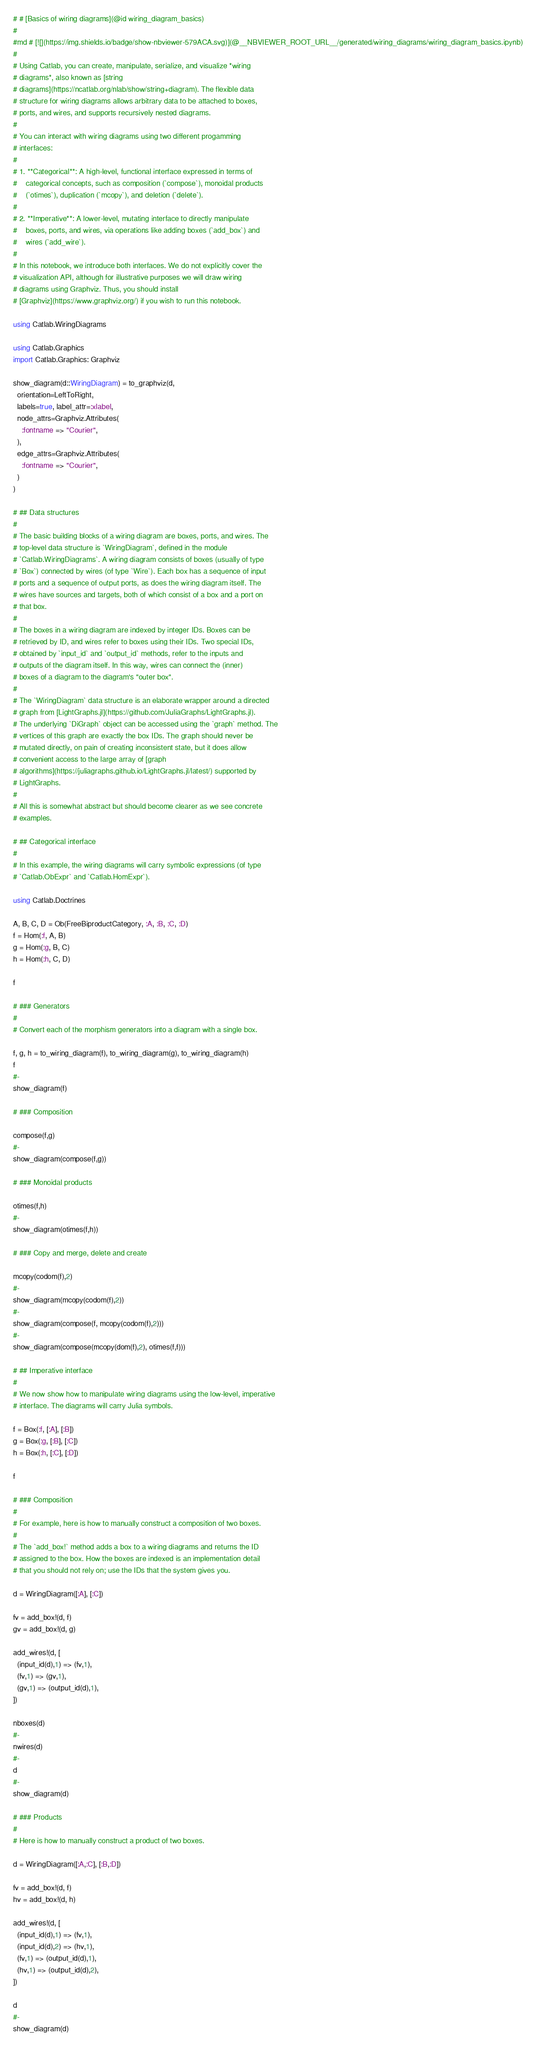<code> <loc_0><loc_0><loc_500><loc_500><_Julia_># # [Basics of wiring diagrams](@id wiring_diagram_basics)
#
#md # [![](https://img.shields.io/badge/show-nbviewer-579ACA.svg)](@__NBVIEWER_ROOT_URL__/generated/wiring_diagrams/wiring_diagram_basics.ipynb)
# 
# Using Catlab, you can create, manipulate, serialize, and visualize *wiring
# diagrams*, also known as [string
# diagrams](https://ncatlab.org/nlab/show/string+diagram). The flexible data
# structure for wiring diagrams allows arbitrary data to be attached to boxes,
# ports, and wires, and supports recursively nested diagrams.
# 
# You can interact with wiring diagrams using two different progamming
# interfaces:
# 
# 1. **Categorical**: A high-level, functional interface expressed in terms of
#    categorical concepts, such as composition (`compose`), monoidal products
#    (`otimes`), duplication (`mcopy`), and deletion (`delete`).
# 
# 2. **Imperative**: A lower-level, mutating interface to directly manipulate
#    boxes, ports, and wires, via operations like adding boxes (`add_box`) and
#    wires (`add_wire`).
# 
# In this notebook, we introduce both interfaces. We do not explicitly cover the
# visualization API, although for illustrative purposes we will draw wiring
# diagrams using Graphviz. Thus, you should install
# [Graphviz](https://www.graphviz.org/) if you wish to run this notebook.

using Catlab.WiringDiagrams

using Catlab.Graphics
import Catlab.Graphics: Graphviz

show_diagram(d::WiringDiagram) = to_graphviz(d,
  orientation=LeftToRight,
  labels=true, label_attr=:xlabel,
  node_attrs=Graphviz.Attributes(
    :fontname => "Courier",
  ),
  edge_attrs=Graphviz.Attributes(
    :fontname => "Courier",
  )
)

# ## Data structures
# 
# The basic building blocks of a wiring diagram are boxes, ports, and wires. The
# top-level data structure is `WiringDiagram`, defined in the module
# `Catlab.WiringDiagrams`. A wiring diagram consists of boxes (usually of type
# `Box`) connected by wires (of type `Wire`). Each box has a sequence of input
# ports and a sequence of output ports, as does the wiring diagram itself. The
# wires have sources and targets, both of which consist of a box and a port on
# that box.
# 
# The boxes in a wiring diagram are indexed by integer IDs. Boxes can be
# retrieved by ID, and wires refer to boxes using their IDs. Two special IDs,
# obtained by `input_id` and `output_id` methods, refer to the inputs and
# outputs of the diagram itself. In this way, wires can connect the (inner)
# boxes of a diagram to the diagram's "outer box".
# 
# The `WiringDiagram` data structure is an elaborate wrapper around a directed
# graph from [LightGraphs.jl](https://github.com/JuliaGraphs/LightGraphs.jl).
# The underlying `DiGraph` object can be accessed using the `graph` method. The
# vertices of this graph are exactly the box IDs. The graph should never be
# mutated directly, on pain of creating inconsistent state, but it does allow
# convenient access to the large array of [graph
# algorithms](https://juliagraphs.github.io/LightGraphs.jl/latest/) supported by
# LightGraphs.
# 
# All this is somewhat abstract but should become clearer as we see concrete 
# examples.

# ## Categorical interface
#
# In this example, the wiring diagrams will carry symbolic expressions (of type
# `Catlab.ObExpr` and `Catlab.HomExpr`).

using Catlab.Doctrines

A, B, C, D = Ob(FreeBiproductCategory, :A, :B, :C, :D)
f = Hom(:f, A, B)
g = Hom(:g, B, C)
h = Hom(:h, C, D)

f

# ### Generators
#
# Convert each of the morphism generators into a diagram with a single box.

f, g, h = to_wiring_diagram(f), to_wiring_diagram(g), to_wiring_diagram(h)
f
#-
show_diagram(f)

# ### Composition

compose(f,g)
#-
show_diagram(compose(f,g))

# ### Monoidal products

otimes(f,h)
#-
show_diagram(otimes(f,h))

# ### Copy and merge, delete and create

mcopy(codom(f),2)
#-
show_diagram(mcopy(codom(f),2))
#-
show_diagram(compose(f, mcopy(codom(f),2)))
#-
show_diagram(compose(mcopy(dom(f),2), otimes(f,f)))

# ## Imperative interface
#
# We now show how to manipulate wiring diagrams using the low-level, imperative
# interface. The diagrams will carry Julia symbols.

f = Box(:f, [:A], [:B])
g = Box(:g, [:B], [:C])
h = Box(:h, [:C], [:D])

f

# ### Composition
#
# For example, here is how to manually construct a composition of two boxes.
#
# The `add_box!` method adds a box to a wiring diagrams and returns the ID
# assigned to the box. How the boxes are indexed is an implementation detail
# that you should not rely on; use the IDs that the system gives you.

d = WiringDiagram([:A], [:C])

fv = add_box!(d, f)
gv = add_box!(d, g)

add_wires!(d, [
  (input_id(d),1) => (fv,1),
  (fv,1) => (gv,1),
  (gv,1) => (output_id(d),1),
])

nboxes(d)
#-
nwires(d)
#-
d
#-
show_diagram(d)

# ### Products
#
# Here is how to manually construct a product of two boxes.

d = WiringDiagram([:A,:C], [:B,:D])

fv = add_box!(d, f)
hv = add_box!(d, h)

add_wires!(d, [
  (input_id(d),1) => (fv,1),
  (input_id(d),2) => (hv,1),
  (fv,1) => (output_id(d),1),
  (hv,1) => (output_id(d),2),
])

d
#-
show_diagram(d)
</code> 